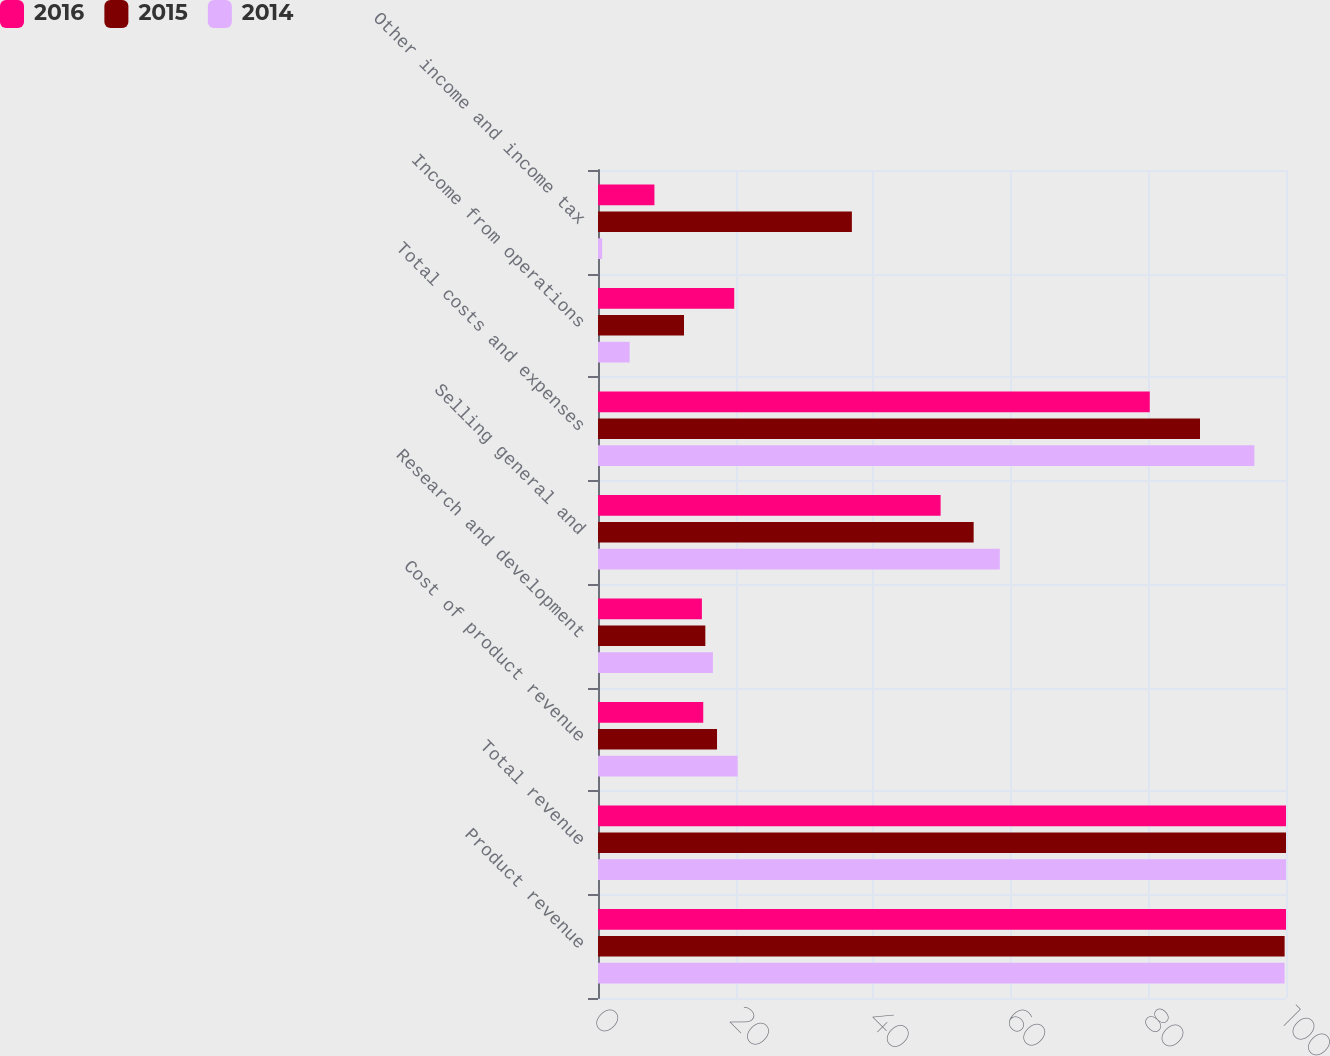Convert chart to OTSL. <chart><loc_0><loc_0><loc_500><loc_500><stacked_bar_chart><ecel><fcel>Product revenue<fcel>Total revenue<fcel>Cost of product revenue<fcel>Research and development<fcel>Selling general and<fcel>Total costs and expenses<fcel>Income from operations<fcel>Other income and income tax<nl><fcel>2016<fcel>100<fcel>100<fcel>15.3<fcel>15.1<fcel>49.8<fcel>80.2<fcel>19.8<fcel>8.2<nl><fcel>2015<fcel>99.8<fcel>100<fcel>17.3<fcel>15.6<fcel>54.6<fcel>87.5<fcel>12.5<fcel>36.9<nl><fcel>2014<fcel>99.8<fcel>100<fcel>20.3<fcel>16.7<fcel>58.4<fcel>95.4<fcel>4.6<fcel>0.6<nl></chart> 